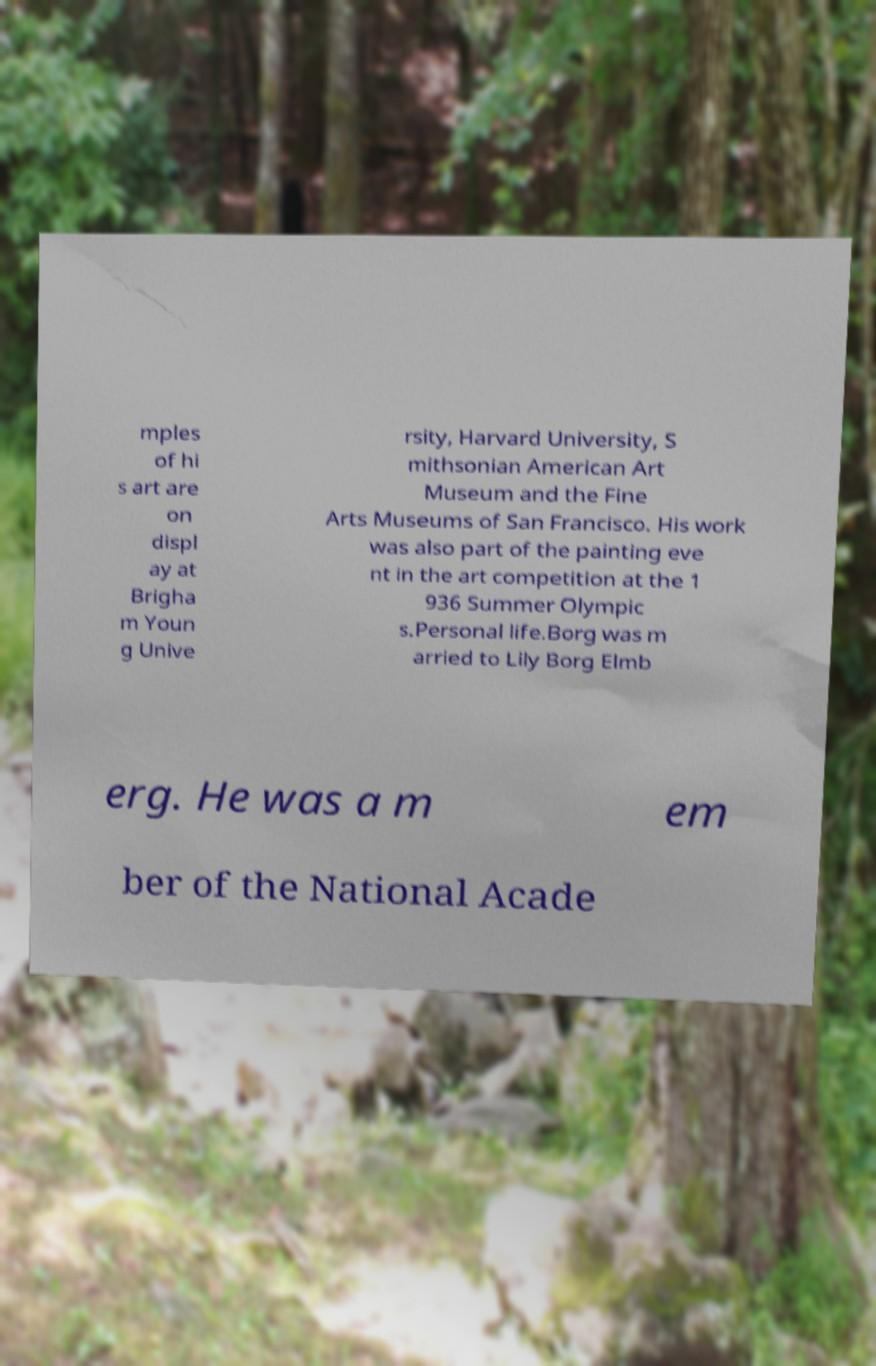Please read and relay the text visible in this image. What does it say? mples of hi s art are on displ ay at Brigha m Youn g Unive rsity, Harvard University, S mithsonian American Art Museum and the Fine Arts Museums of San Francisco. His work was also part of the painting eve nt in the art competition at the 1 936 Summer Olympic s.Personal life.Borg was m arried to Lily Borg Elmb erg. He was a m em ber of the National Acade 